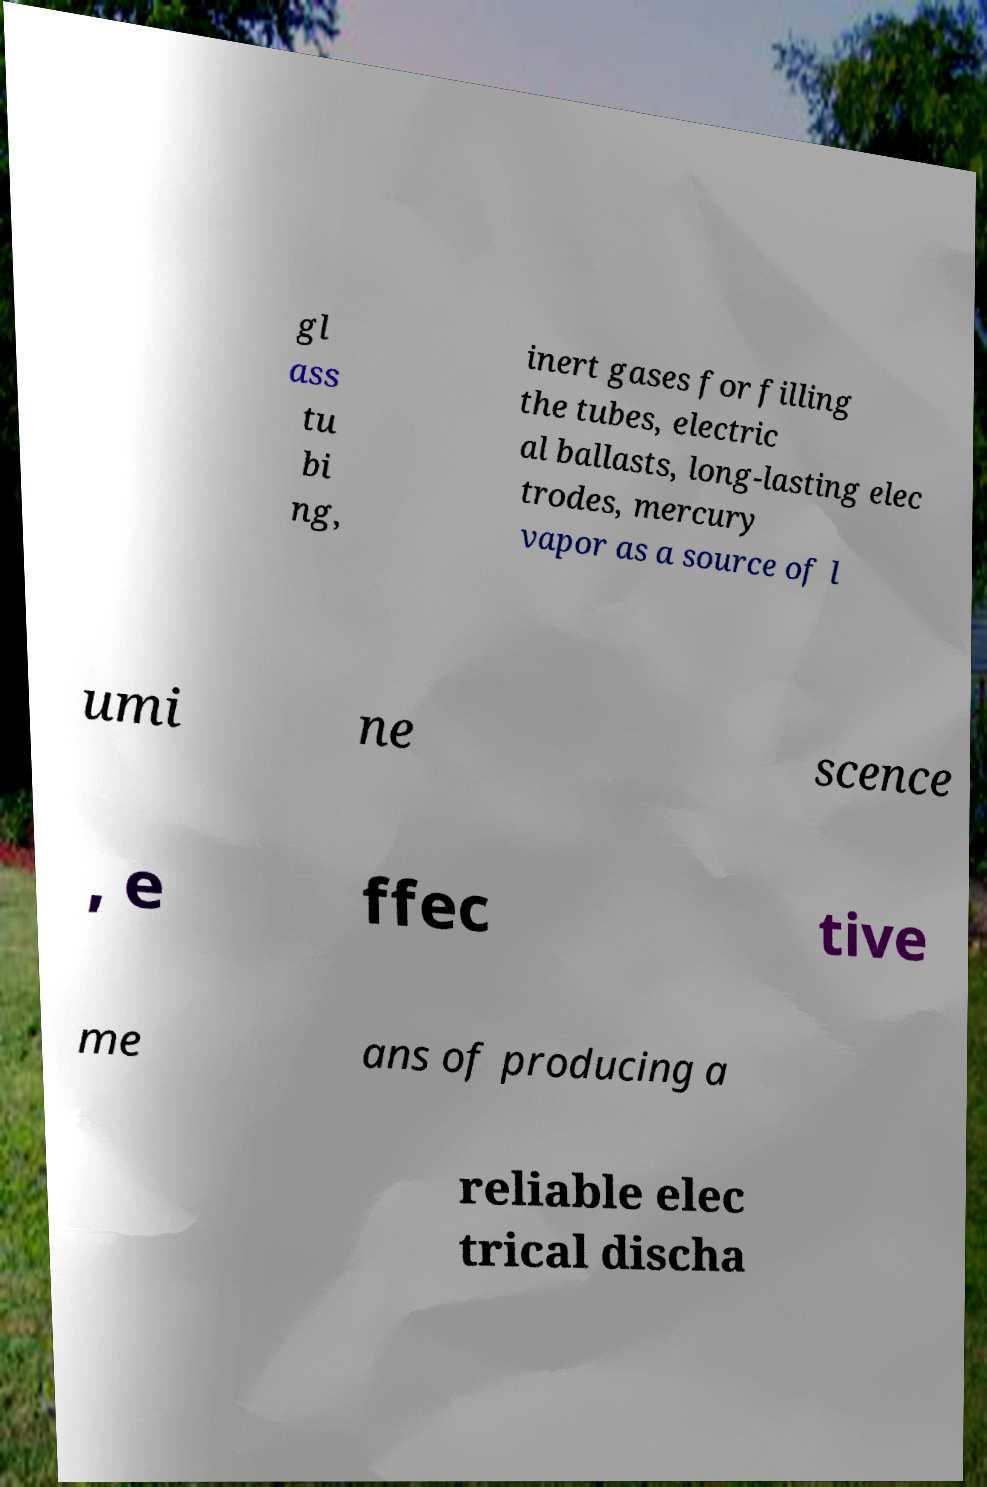Please identify and transcribe the text found in this image. gl ass tu bi ng, inert gases for filling the tubes, electric al ballasts, long-lasting elec trodes, mercury vapor as a source of l umi ne scence , e ffec tive me ans of producing a reliable elec trical discha 